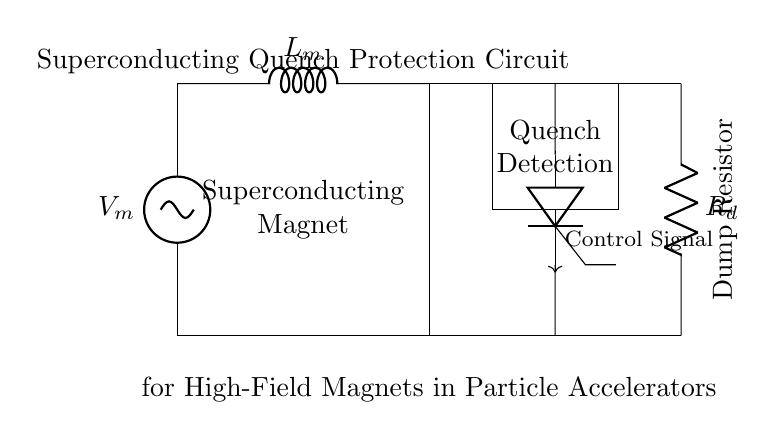What is the voltage of the superconducting magnet? The voltage \( V_m \) is indicated at the top of the superconducting magnet in the circuit diagram.
Answer: V_m What is the purpose of the dump resistor? The dump resistor \( R_d \) is connected to allow current to be safely dissipated when the superconducting magnet quenches, effectively protecting the system.
Answer: Quench protection How many components are in the quench detection system? The quench detection system is represented as a single rectangle, thus it counts as one component.
Answer: One Which component provides the control signal? The control signal is generated at the node corresponding to the thyristor switch, specifically indicated by the arrow in the circuit diagram.
Answer: Thyristor What type of component is used for switching in this circuit? A thyristor is specifically used as the switching component in this protection circuit, as indicated in the diagram.
Answer: Thyristor What happens to the circuit during a quench? During a quench, the control signal engages the thyristor, allowing current to bypass the superconducting magnet through the dump resistor, resulting in a safe discharge of energy.
Answer: Current bypass What is the primary role of the quench detection system? The quench detection system is responsible for identifying when a quench occurs in the superconductor and subsequently activating the protection measures.
Answer: Detection 